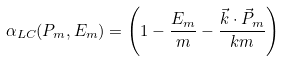Convert formula to latex. <formula><loc_0><loc_0><loc_500><loc_500>\alpha _ { L C } ( P _ { m } , E _ { m } ) = \left ( 1 - \frac { E _ { m } } { m } - \frac { \vec { k } \cdot \vec { P } _ { m } } { k m } \right )</formula> 